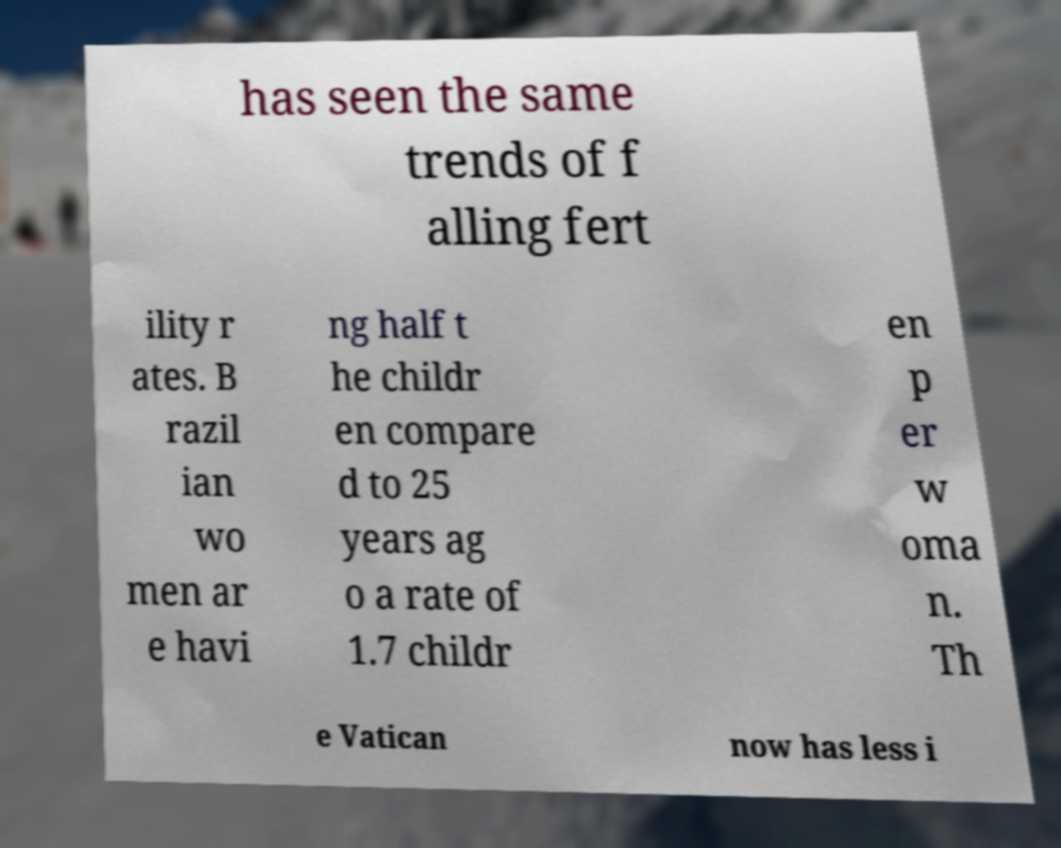There's text embedded in this image that I need extracted. Can you transcribe it verbatim? has seen the same trends of f alling fert ility r ates. B razil ian wo men ar e havi ng half t he childr en compare d to 25 years ag o a rate of 1.7 childr en p er w oma n. Th e Vatican now has less i 